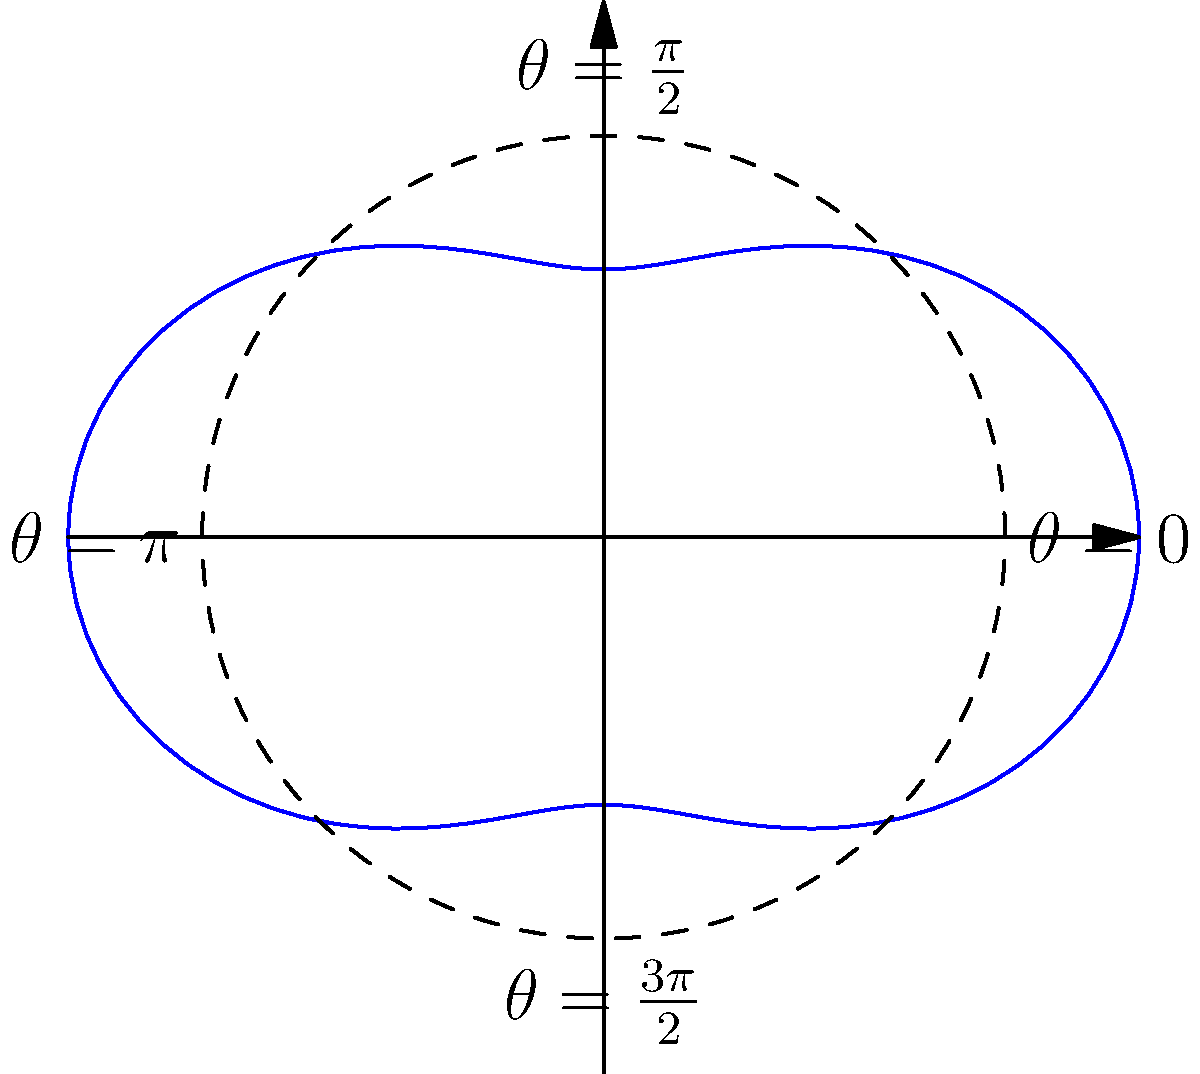A rotating stage prop is designed to follow the polar curve $r = 3 + \cos(2\theta)$. As the playwright's representative, you need to determine the maximum radial distance of the prop from the stage center to ensure proper clearance during performances. What is this maximum distance? To find the maximum radial distance, we need to follow these steps:

1) The given polar equation is $r = 3 + \cos(2\theta)$.

2) The maximum value of $r$ will occur when $\cos(2\theta)$ is at its maximum, which is 1.

3) Therefore, the maximum value of $r$ is:

   $$r_{max} = 3 + 1 = 4$$

4) This means that the prop will extend a maximum of 4 units from the center of the stage.

5) It's important to note that the minimum value would occur when $\cos(2\theta) = -1$, giving $r_{min} = 3 - 1 = 2$.

6) The difference between the maximum and minimum radii (4 - 2 = 2) represents the total variation in the prop's distance from the center as it rotates.

Understanding this maximum distance is crucial for ensuring proper stage design, lighting setup, and safety clearances during performances.
Answer: 4 units 